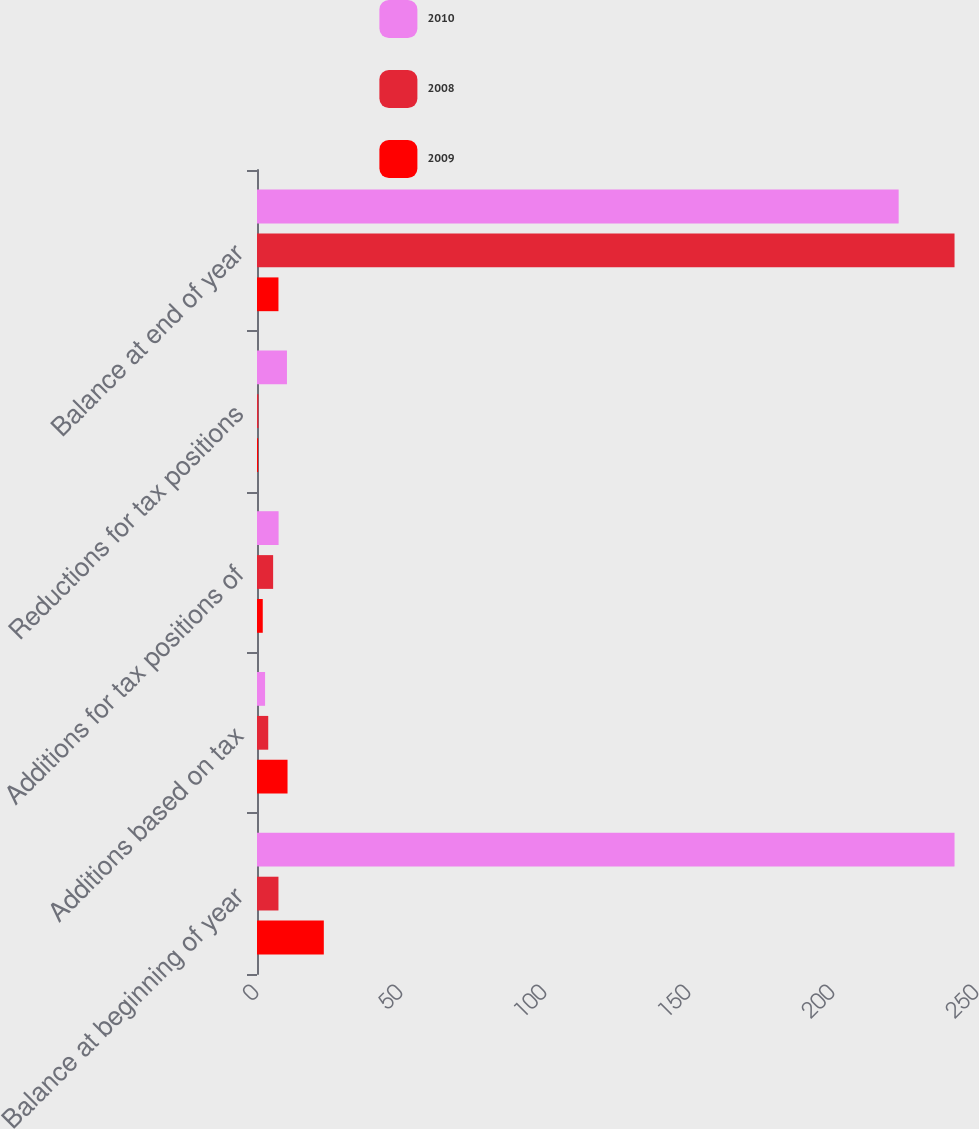<chart> <loc_0><loc_0><loc_500><loc_500><stacked_bar_chart><ecel><fcel>Balance at beginning of year<fcel>Additions based on tax<fcel>Additions for tax positions of<fcel>Reductions for tax positions<fcel>Balance at end of year<nl><fcel>2010<fcel>242.2<fcel>2.8<fcel>7.5<fcel>10.4<fcel>222.8<nl><fcel>2008<fcel>7.45<fcel>3.9<fcel>5.6<fcel>0.5<fcel>242.2<nl><fcel>2009<fcel>23.2<fcel>10.6<fcel>2<fcel>0.4<fcel>7.45<nl></chart> 